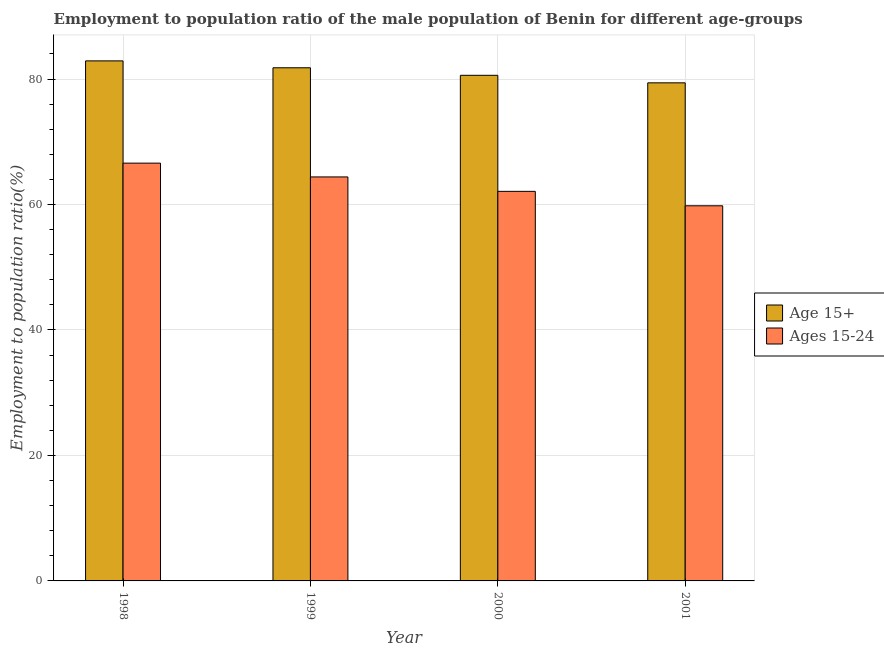How many different coloured bars are there?
Provide a short and direct response. 2. How many groups of bars are there?
Offer a terse response. 4. Are the number of bars on each tick of the X-axis equal?
Keep it short and to the point. Yes. How many bars are there on the 3rd tick from the left?
Make the answer very short. 2. In how many cases, is the number of bars for a given year not equal to the number of legend labels?
Provide a short and direct response. 0. What is the employment to population ratio(age 15-24) in 2000?
Your answer should be very brief. 62.1. Across all years, what is the maximum employment to population ratio(age 15+)?
Your answer should be compact. 82.9. Across all years, what is the minimum employment to population ratio(age 15-24)?
Your answer should be compact. 59.8. In which year was the employment to population ratio(age 15+) minimum?
Make the answer very short. 2001. What is the total employment to population ratio(age 15-24) in the graph?
Ensure brevity in your answer.  252.9. What is the difference between the employment to population ratio(age 15+) in 1998 and that in 2000?
Your response must be concise. 2.3. What is the difference between the employment to population ratio(age 15-24) in 2001 and the employment to population ratio(age 15+) in 2000?
Offer a very short reply. -2.3. What is the average employment to population ratio(age 15-24) per year?
Offer a terse response. 63.22. In the year 2001, what is the difference between the employment to population ratio(age 15-24) and employment to population ratio(age 15+)?
Ensure brevity in your answer.  0. What is the ratio of the employment to population ratio(age 15+) in 1998 to that in 1999?
Your answer should be very brief. 1.01. Is the difference between the employment to population ratio(age 15+) in 1999 and 2001 greater than the difference between the employment to population ratio(age 15-24) in 1999 and 2001?
Offer a terse response. No. What is the difference between the highest and the second highest employment to population ratio(age 15-24)?
Provide a succinct answer. 2.2. What does the 2nd bar from the left in 2001 represents?
Offer a terse response. Ages 15-24. What does the 1st bar from the right in 1999 represents?
Keep it short and to the point. Ages 15-24. Are all the bars in the graph horizontal?
Provide a short and direct response. No. Does the graph contain grids?
Make the answer very short. Yes. Where does the legend appear in the graph?
Your response must be concise. Center right. How many legend labels are there?
Make the answer very short. 2. How are the legend labels stacked?
Your answer should be very brief. Vertical. What is the title of the graph?
Provide a short and direct response. Employment to population ratio of the male population of Benin for different age-groups. What is the label or title of the X-axis?
Your answer should be compact. Year. What is the label or title of the Y-axis?
Ensure brevity in your answer.  Employment to population ratio(%). What is the Employment to population ratio(%) of Age 15+ in 1998?
Your response must be concise. 82.9. What is the Employment to population ratio(%) of Ages 15-24 in 1998?
Offer a very short reply. 66.6. What is the Employment to population ratio(%) of Age 15+ in 1999?
Make the answer very short. 81.8. What is the Employment to population ratio(%) in Ages 15-24 in 1999?
Keep it short and to the point. 64.4. What is the Employment to population ratio(%) in Age 15+ in 2000?
Your answer should be very brief. 80.6. What is the Employment to population ratio(%) in Ages 15-24 in 2000?
Your answer should be very brief. 62.1. What is the Employment to population ratio(%) in Age 15+ in 2001?
Provide a short and direct response. 79.4. What is the Employment to population ratio(%) of Ages 15-24 in 2001?
Your answer should be very brief. 59.8. Across all years, what is the maximum Employment to population ratio(%) of Age 15+?
Ensure brevity in your answer.  82.9. Across all years, what is the maximum Employment to population ratio(%) of Ages 15-24?
Your answer should be compact. 66.6. Across all years, what is the minimum Employment to population ratio(%) in Age 15+?
Provide a succinct answer. 79.4. Across all years, what is the minimum Employment to population ratio(%) of Ages 15-24?
Keep it short and to the point. 59.8. What is the total Employment to population ratio(%) of Age 15+ in the graph?
Provide a short and direct response. 324.7. What is the total Employment to population ratio(%) in Ages 15-24 in the graph?
Provide a short and direct response. 252.9. What is the difference between the Employment to population ratio(%) of Ages 15-24 in 1998 and that in 1999?
Offer a terse response. 2.2. What is the difference between the Employment to population ratio(%) of Age 15+ in 1998 and that in 2001?
Provide a succinct answer. 3.5. What is the difference between the Employment to population ratio(%) in Age 15+ in 1999 and that in 2000?
Offer a terse response. 1.2. What is the difference between the Employment to population ratio(%) of Age 15+ in 1999 and that in 2001?
Your answer should be very brief. 2.4. What is the difference between the Employment to population ratio(%) in Ages 15-24 in 1999 and that in 2001?
Offer a very short reply. 4.6. What is the difference between the Employment to population ratio(%) of Ages 15-24 in 2000 and that in 2001?
Provide a short and direct response. 2.3. What is the difference between the Employment to population ratio(%) of Age 15+ in 1998 and the Employment to population ratio(%) of Ages 15-24 in 1999?
Offer a terse response. 18.5. What is the difference between the Employment to population ratio(%) in Age 15+ in 1998 and the Employment to population ratio(%) in Ages 15-24 in 2000?
Your answer should be very brief. 20.8. What is the difference between the Employment to population ratio(%) in Age 15+ in 1998 and the Employment to population ratio(%) in Ages 15-24 in 2001?
Your answer should be very brief. 23.1. What is the difference between the Employment to population ratio(%) in Age 15+ in 1999 and the Employment to population ratio(%) in Ages 15-24 in 2001?
Provide a succinct answer. 22. What is the difference between the Employment to population ratio(%) in Age 15+ in 2000 and the Employment to population ratio(%) in Ages 15-24 in 2001?
Keep it short and to the point. 20.8. What is the average Employment to population ratio(%) in Age 15+ per year?
Your response must be concise. 81.17. What is the average Employment to population ratio(%) in Ages 15-24 per year?
Provide a succinct answer. 63.23. In the year 1999, what is the difference between the Employment to population ratio(%) of Age 15+ and Employment to population ratio(%) of Ages 15-24?
Your answer should be very brief. 17.4. In the year 2000, what is the difference between the Employment to population ratio(%) of Age 15+ and Employment to population ratio(%) of Ages 15-24?
Your response must be concise. 18.5. In the year 2001, what is the difference between the Employment to population ratio(%) in Age 15+ and Employment to population ratio(%) in Ages 15-24?
Keep it short and to the point. 19.6. What is the ratio of the Employment to population ratio(%) in Age 15+ in 1998 to that in 1999?
Ensure brevity in your answer.  1.01. What is the ratio of the Employment to population ratio(%) of Ages 15-24 in 1998 to that in 1999?
Make the answer very short. 1.03. What is the ratio of the Employment to population ratio(%) in Age 15+ in 1998 to that in 2000?
Keep it short and to the point. 1.03. What is the ratio of the Employment to population ratio(%) in Ages 15-24 in 1998 to that in 2000?
Your answer should be very brief. 1.07. What is the ratio of the Employment to population ratio(%) in Age 15+ in 1998 to that in 2001?
Provide a short and direct response. 1.04. What is the ratio of the Employment to population ratio(%) in Ages 15-24 in 1998 to that in 2001?
Your answer should be very brief. 1.11. What is the ratio of the Employment to population ratio(%) in Age 15+ in 1999 to that in 2000?
Make the answer very short. 1.01. What is the ratio of the Employment to population ratio(%) in Age 15+ in 1999 to that in 2001?
Your response must be concise. 1.03. What is the ratio of the Employment to population ratio(%) in Ages 15-24 in 1999 to that in 2001?
Your response must be concise. 1.08. What is the ratio of the Employment to population ratio(%) in Age 15+ in 2000 to that in 2001?
Make the answer very short. 1.02. What is the ratio of the Employment to population ratio(%) in Ages 15-24 in 2000 to that in 2001?
Provide a short and direct response. 1.04. What is the difference between the highest and the second highest Employment to population ratio(%) in Age 15+?
Your response must be concise. 1.1. 